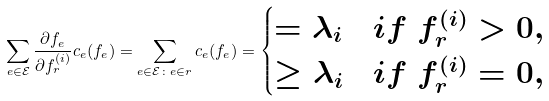Convert formula to latex. <formula><loc_0><loc_0><loc_500><loc_500>\sum _ { e \in \mathcal { E } } \frac { \partial f _ { e } } { \partial f ^ { ( i ) } _ { r } } c _ { e } ( f _ { e } ) = \sum _ { e \in \mathcal { E } \colon e \in r } c _ { e } ( f _ { e } ) = \begin{cases} = \lambda _ { i } & i f $ $ f _ { r } ^ { ( i ) } > 0 , \\ \geq \lambda _ { i } & i f $ $ f _ { r } ^ { ( i ) } = 0 , \end{cases}</formula> 